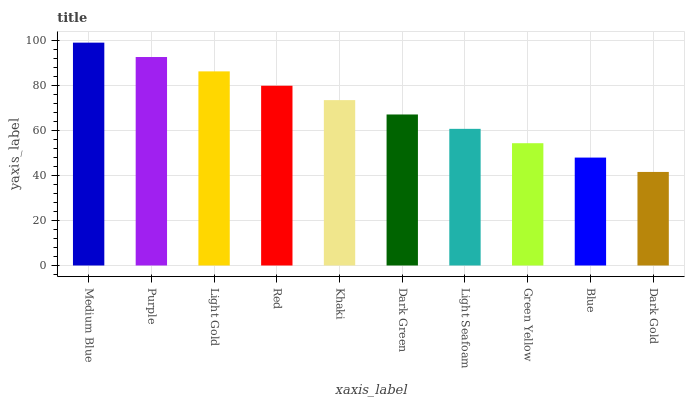Is Dark Gold the minimum?
Answer yes or no. Yes. Is Medium Blue the maximum?
Answer yes or no. Yes. Is Purple the minimum?
Answer yes or no. No. Is Purple the maximum?
Answer yes or no. No. Is Medium Blue greater than Purple?
Answer yes or no. Yes. Is Purple less than Medium Blue?
Answer yes or no. Yes. Is Purple greater than Medium Blue?
Answer yes or no. No. Is Medium Blue less than Purple?
Answer yes or no. No. Is Khaki the high median?
Answer yes or no. Yes. Is Dark Green the low median?
Answer yes or no. Yes. Is Dark Green the high median?
Answer yes or no. No. Is Green Yellow the low median?
Answer yes or no. No. 